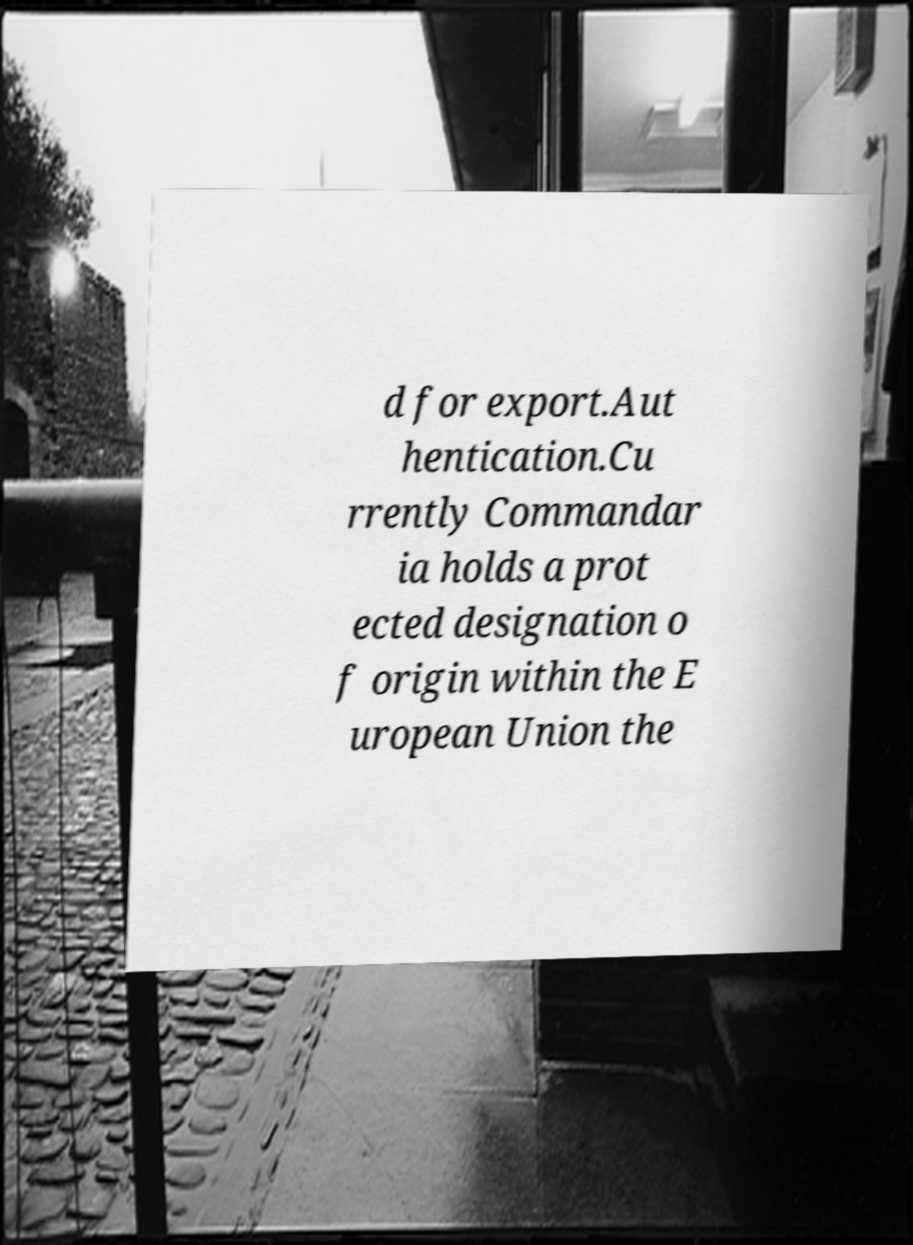Please identify and transcribe the text found in this image. d for export.Aut hentication.Cu rrently Commandar ia holds a prot ected designation o f origin within the E uropean Union the 